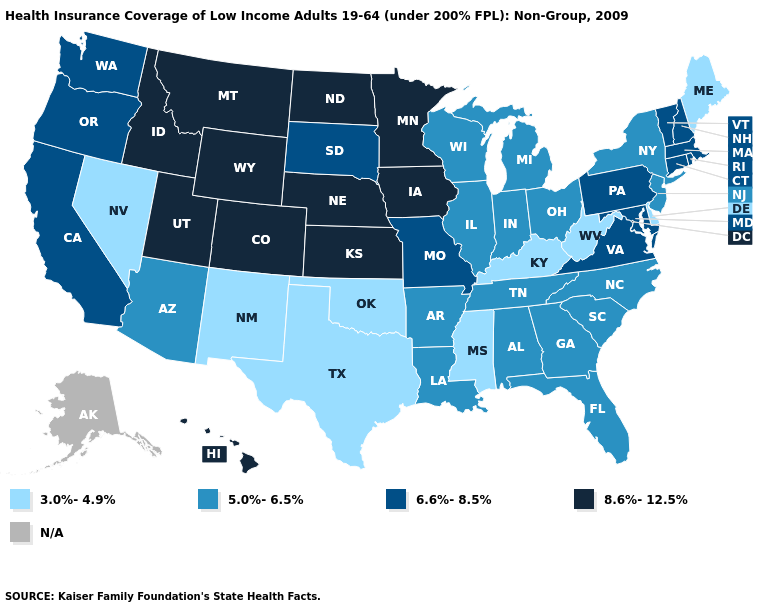How many symbols are there in the legend?
Quick response, please. 5. Does New Jersey have the highest value in the Northeast?
Be succinct. No. Which states hav the highest value in the West?
Give a very brief answer. Colorado, Hawaii, Idaho, Montana, Utah, Wyoming. Among the states that border Colorado , does New Mexico have the highest value?
Give a very brief answer. No. Among the states that border Montana , does Wyoming have the highest value?
Write a very short answer. Yes. What is the value of Massachusetts?
Quick response, please. 6.6%-8.5%. What is the highest value in the South ?
Write a very short answer. 6.6%-8.5%. Among the states that border North Dakota , which have the highest value?
Concise answer only. Minnesota, Montana. Name the states that have a value in the range 3.0%-4.9%?
Quick response, please. Delaware, Kentucky, Maine, Mississippi, Nevada, New Mexico, Oklahoma, Texas, West Virginia. Name the states that have a value in the range 8.6%-12.5%?
Keep it brief. Colorado, Hawaii, Idaho, Iowa, Kansas, Minnesota, Montana, Nebraska, North Dakota, Utah, Wyoming. Among the states that border Washington , does Oregon have the highest value?
Answer briefly. No. Does Utah have the highest value in the USA?
Concise answer only. Yes. 